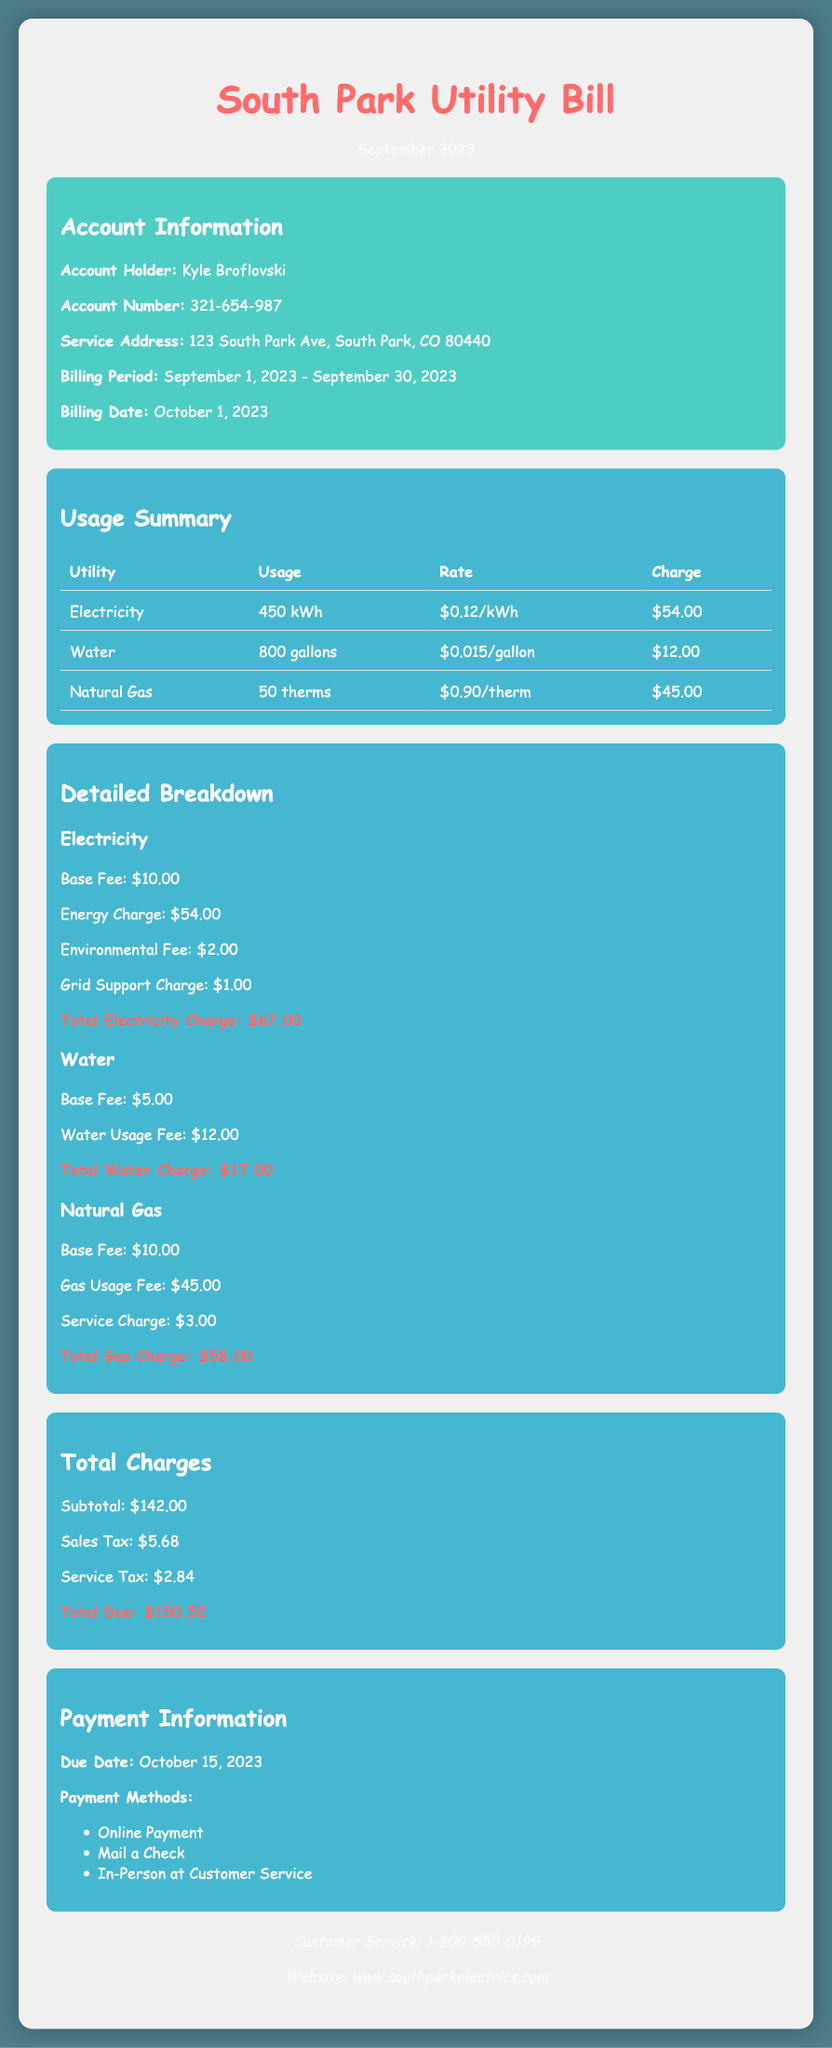What is the account holder's name? The document specifies the account holder's name as Kyle Broflovski.
Answer: Kyle Broflovski What is the total electricity charge? The total electricity charge, including the base fee and other charges, is detailed in the document as $67.00.
Answer: $67.00 How many gallons of water were used? The usage summary indicates that 800 gallons of water were utilized during the billing period.
Answer: 800 gallons What is the subtotal of all charges? The total charges section lists the subtotal as $142.00 before taxes are added.
Answer: $142.00 What is the due date for payment? The payment information section provides the due date as October 15, 2023.
Answer: October 15, 2023 What is the total due amount? The document lists the total amount due, which includes taxes, as $150.52.
Answer: $150.52 What is the service address? The account information section specifies the service address as 123 South Park Ave, South Park, CO 80440.
Answer: 123 South Park Ave, South Park, CO 80440 What is the rate for natural gas per therm? The usage summary states that the rate for natural gas is $0.90 per therm.
Answer: $0.90/therm What payment methods are available? The payment information section includes three options for payment methods, detailing online payment, mail a check, and in-person at customer service.
Answer: Online Payment, Mail a Check, In-Person at Customer Service 